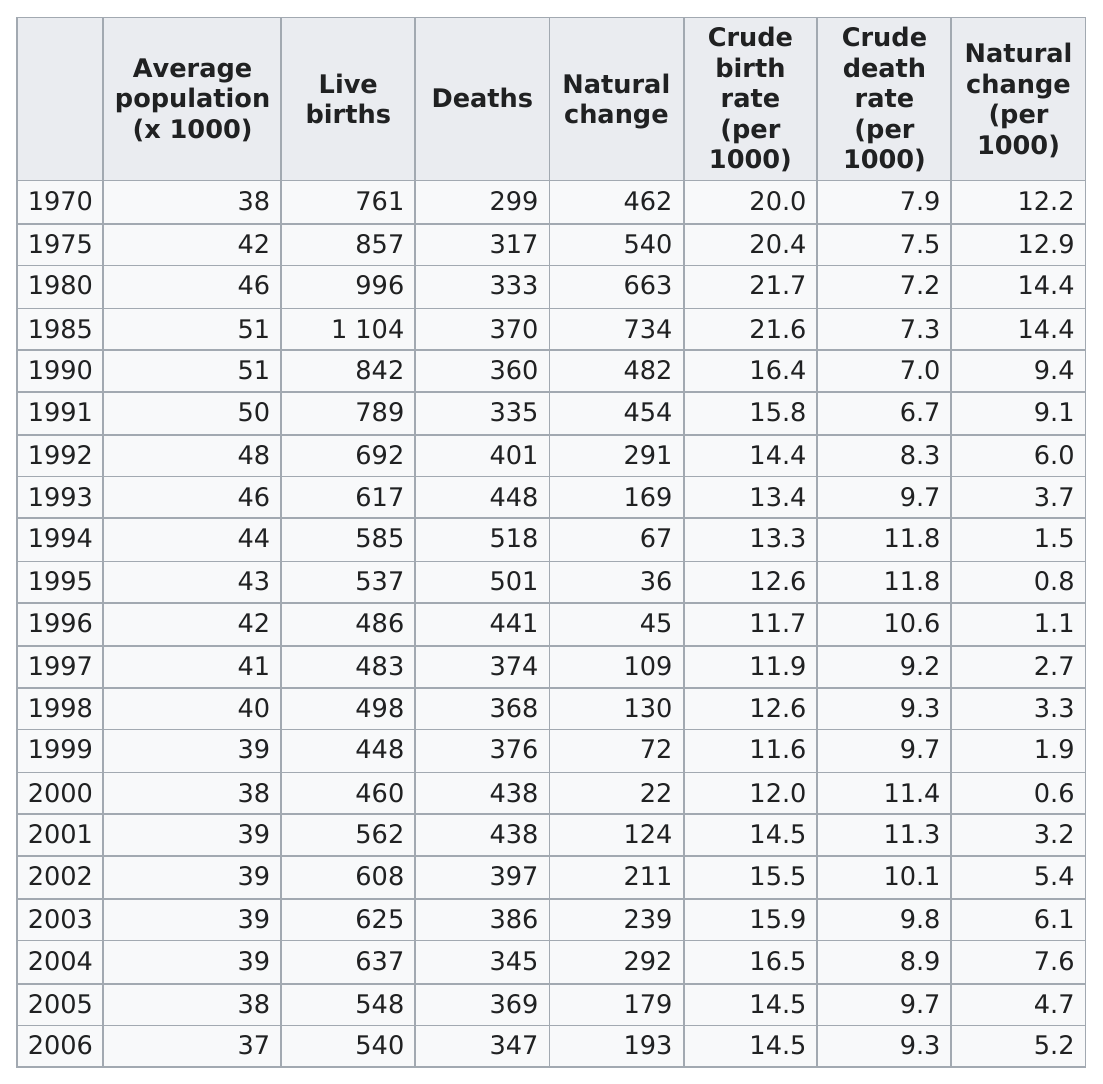Draw attention to some important aspects in this diagram. In 518, the year had the largest number of deaths. In the year 1990, the population was X, and in the year 2000, the population was X + 10. In the year 1985, the number of live births exceeded 1,000 for the first time. The years 1985, 1990, and 1991 had an average population of at least 50,000. The average population in 2003 was approximately 39,000. 